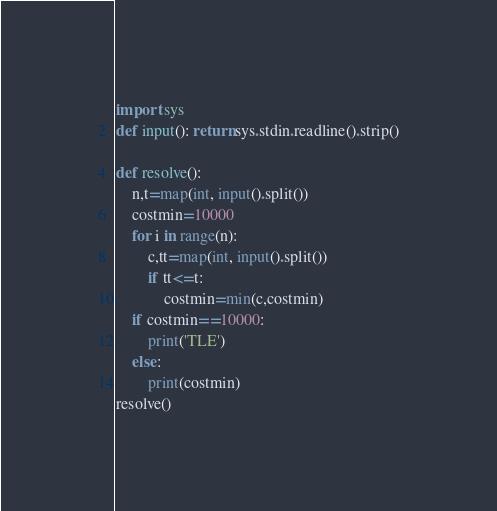<code> <loc_0><loc_0><loc_500><loc_500><_Python_>import sys
def input(): return sys.stdin.readline().strip()

def resolve():
    n,t=map(int, input().split())
    costmin=10000
    for i in range(n):
        c,tt=map(int, input().split())
        if tt<=t:
            costmin=min(c,costmin)
    if costmin==10000:
        print('TLE')
    else:
        print(costmin)
resolve()</code> 